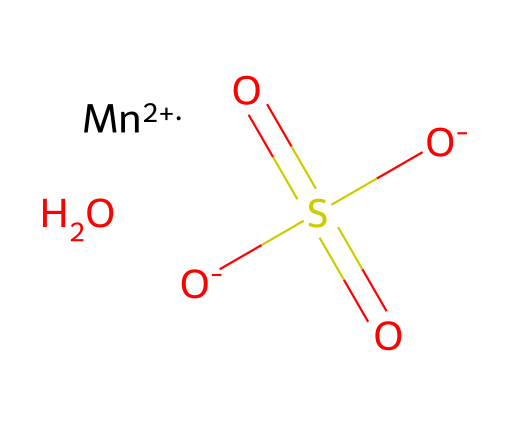What is the chemical name of this compound? The SMILES representation includes a manganese atom followed by the sulfate ion. The presence of manganese and the sulfate group indicates that the compound is manganese(II) sulfate monohydrate.
Answer: manganese(II) sulfate monohydrate How many oxygen atoms are present in the structure? The sulfate part of the structure includes four oxygen atoms in its representation (two O- and two in the SO4). The water molecule contributes one additional oxygen. Thus, a total of 5 oxygen atoms are present.
Answer: 5 What is the oxidation state of manganese in this compound? The notation [Mn+2] indicates that manganese has an oxidation state of +2 in this compound. This is inferred directly from the representation of manganese in the SMILES notation.
Answer: +2 What type of bond connects manganese to the sulfate ion? In coordination compounds, the metal ion (manganese) combines with the sulfate ion through ionic interactions, as indicated by the electrostatic attraction between the positively charged manganese and the negatively charged sulfate.
Answer: ionic How many hydrogen atoms are included in the structure? The chemical structure includes a monohydrate component (O in the SMILES), which represents one water molecule. A water molecule has two hydrogen atoms. Therefore, there are 2 hydrogen atoms present in the structure.
Answer: 2 What is the coordination number of manganese in this compound? Manganese(II) typically forms six coordination bonds in coordination compounds. In this case, it is coordinated by four oxygen atoms from sulfate and possibly two from water, leading to a coordination number of 6.
Answer: 6 Is manganese(II) sulfate monohydrate acidic or basic? This compound is generally considered neutral, as sulfate ions do not significantly affect the pH. Thus, it does not produce acid or a base in solution.
Answer: neutral 